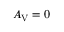Convert formula to latex. <formula><loc_0><loc_0><loc_500><loc_500>A _ { V } = 0</formula> 